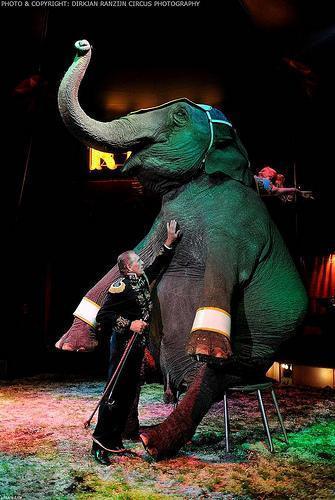How many elephants are there?
Give a very brief answer. 1. 